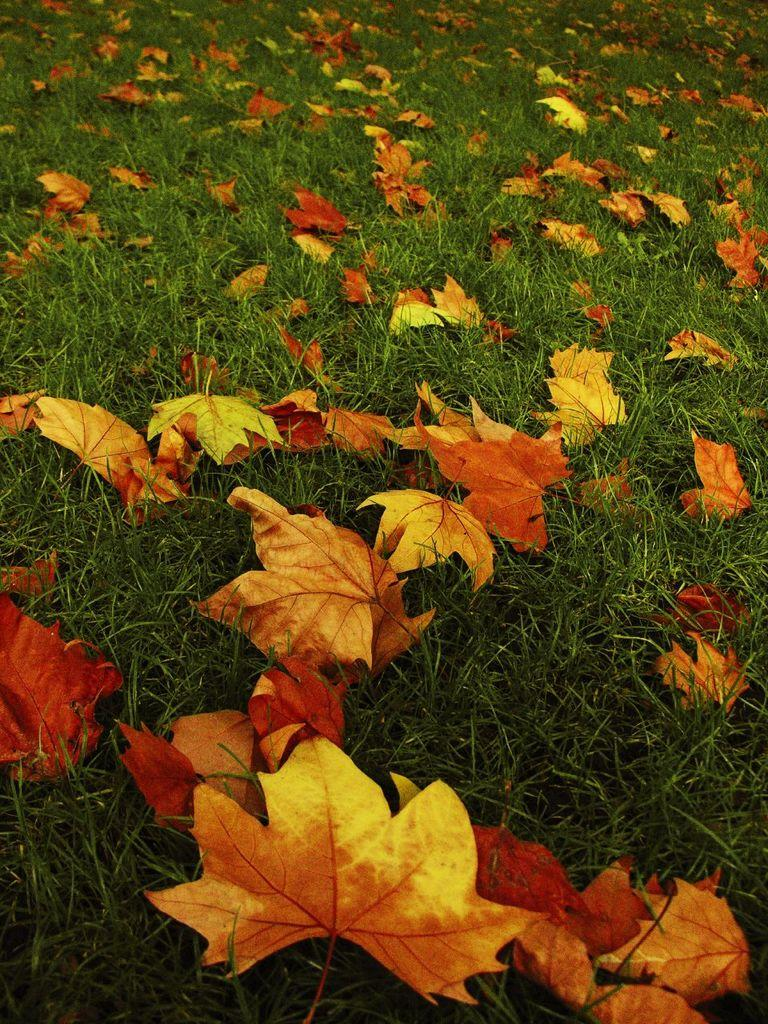What type of vegetation can be seen in the image? There are leaves in the image. What color is the grass in the image? The grass in the image is green. What type of yarn is being used to create the spot in the lake in the image? There is no yarn, spot, or lake present in the image. 